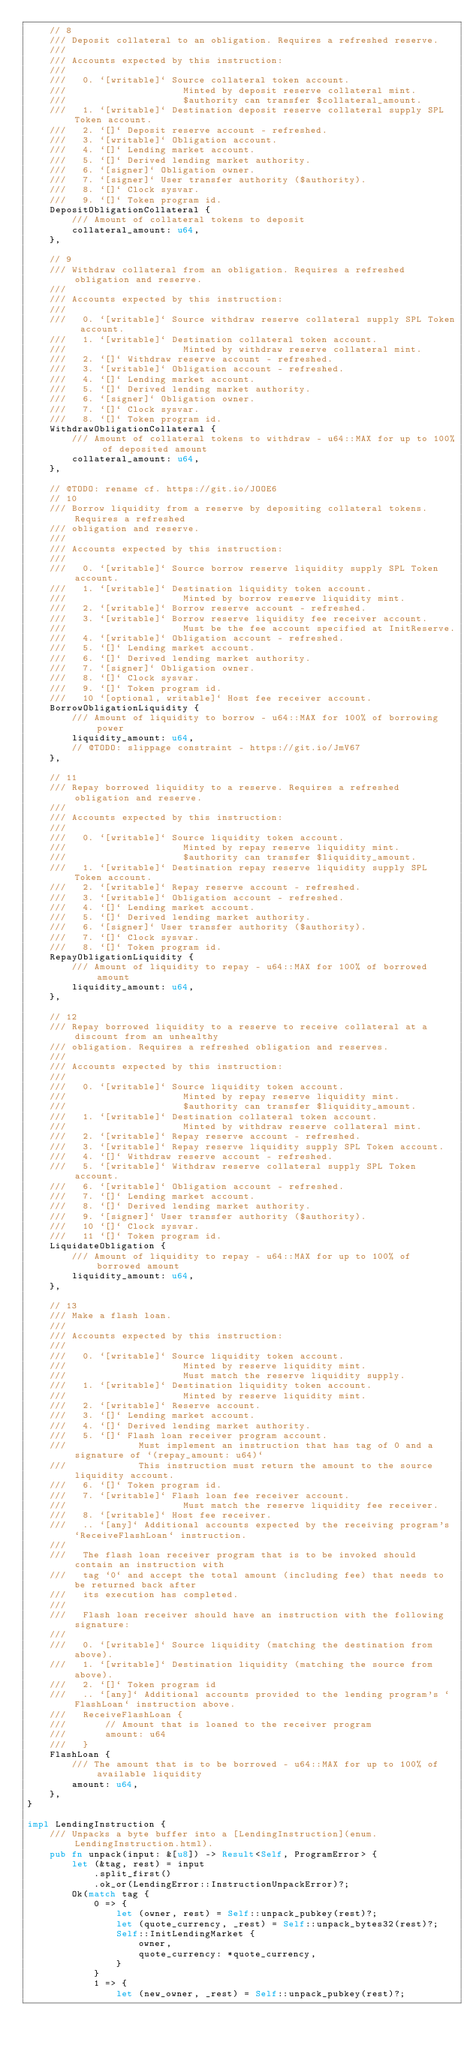<code> <loc_0><loc_0><loc_500><loc_500><_Rust_>    // 8
    /// Deposit collateral to an obligation. Requires a refreshed reserve.
    ///
    /// Accounts expected by this instruction:
    ///
    ///   0. `[writable]` Source collateral token account.
    ///                     Minted by deposit reserve collateral mint.
    ///                     $authority can transfer $collateral_amount.
    ///   1. `[writable]` Destination deposit reserve collateral supply SPL Token account.
    ///   2. `[]` Deposit reserve account - refreshed.
    ///   3. `[writable]` Obligation account.
    ///   4. `[]` Lending market account.
    ///   5. `[]` Derived lending market authority.
    ///   6. `[signer]` Obligation owner.
    ///   7. `[signer]` User transfer authority ($authority).
    ///   8. `[]` Clock sysvar.
    ///   9. `[]` Token program id.
    DepositObligationCollateral {
        /// Amount of collateral tokens to deposit
        collateral_amount: u64,
    },

    // 9
    /// Withdraw collateral from an obligation. Requires a refreshed obligation and reserve.
    ///
    /// Accounts expected by this instruction:
    ///
    ///   0. `[writable]` Source withdraw reserve collateral supply SPL Token account.
    ///   1. `[writable]` Destination collateral token account.
    ///                     Minted by withdraw reserve collateral mint.
    ///   2. `[]` Withdraw reserve account - refreshed.
    ///   3. `[writable]` Obligation account - refreshed.
    ///   4. `[]` Lending market account.
    ///   5. `[]` Derived lending market authority.
    ///   6. `[signer]` Obligation owner.
    ///   7. `[]` Clock sysvar.
    ///   8. `[]` Token program id.
    WithdrawObligationCollateral {
        /// Amount of collateral tokens to withdraw - u64::MAX for up to 100% of deposited amount
        collateral_amount: u64,
    },

    // @TODO: rename cf. https://git.io/JOOE6
    // 10
    /// Borrow liquidity from a reserve by depositing collateral tokens. Requires a refreshed
    /// obligation and reserve.
    ///
    /// Accounts expected by this instruction:
    ///
    ///   0. `[writable]` Source borrow reserve liquidity supply SPL Token account.
    ///   1. `[writable]` Destination liquidity token account.
    ///                     Minted by borrow reserve liquidity mint.
    ///   2. `[writable]` Borrow reserve account - refreshed.
    ///   3. `[writable]` Borrow reserve liquidity fee receiver account.
    ///                     Must be the fee account specified at InitReserve.
    ///   4. `[writable]` Obligation account - refreshed.
    ///   5. `[]` Lending market account.
    ///   6. `[]` Derived lending market authority.
    ///   7. `[signer]` Obligation owner.
    ///   8. `[]` Clock sysvar.
    ///   9. `[]` Token program id.
    ///   10 `[optional, writable]` Host fee receiver account.
    BorrowObligationLiquidity {
        /// Amount of liquidity to borrow - u64::MAX for 100% of borrowing power
        liquidity_amount: u64,
        // @TODO: slippage constraint - https://git.io/JmV67
    },

    // 11
    /// Repay borrowed liquidity to a reserve. Requires a refreshed obligation and reserve.
    ///
    /// Accounts expected by this instruction:
    ///
    ///   0. `[writable]` Source liquidity token account.
    ///                     Minted by repay reserve liquidity mint.
    ///                     $authority can transfer $liquidity_amount.
    ///   1. `[writable]` Destination repay reserve liquidity supply SPL Token account.
    ///   2. `[writable]` Repay reserve account - refreshed.
    ///   3. `[writable]` Obligation account - refreshed.
    ///   4. `[]` Lending market account.
    ///   5. `[]` Derived lending market authority.
    ///   6. `[signer]` User transfer authority ($authority).
    ///   7. `[]` Clock sysvar.
    ///   8. `[]` Token program id.
    RepayObligationLiquidity {
        /// Amount of liquidity to repay - u64::MAX for 100% of borrowed amount
        liquidity_amount: u64,
    },

    // 12
    /// Repay borrowed liquidity to a reserve to receive collateral at a discount from an unhealthy
    /// obligation. Requires a refreshed obligation and reserves.
    ///
    /// Accounts expected by this instruction:
    ///
    ///   0. `[writable]` Source liquidity token account.
    ///                     Minted by repay reserve liquidity mint.
    ///                     $authority can transfer $liquidity_amount.
    ///   1. `[writable]` Destination collateral token account.
    ///                     Minted by withdraw reserve collateral mint.
    ///   2. `[writable]` Repay reserve account - refreshed.
    ///   3. `[writable]` Repay reserve liquidity supply SPL Token account.
    ///   4. `[]` Withdraw reserve account - refreshed.
    ///   5. `[writable]` Withdraw reserve collateral supply SPL Token account.
    ///   6. `[writable]` Obligation account - refreshed.
    ///   7. `[]` Lending market account.
    ///   8. `[]` Derived lending market authority.
    ///   9. `[signer]` User transfer authority ($authority).
    ///   10 `[]` Clock sysvar.
    ///   11 `[]` Token program id.
    LiquidateObligation {
        /// Amount of liquidity to repay - u64::MAX for up to 100% of borrowed amount
        liquidity_amount: u64,
    },

    // 13
    /// Make a flash loan.
    ///
    /// Accounts expected by this instruction:
    ///
    ///   0. `[writable]` Source liquidity token account.
    ///                     Minted by reserve liquidity mint.
    ///                     Must match the reserve liquidity supply.
    ///   1. `[writable]` Destination liquidity token account.
    ///                     Minted by reserve liquidity mint.
    ///   2. `[writable]` Reserve account.
    ///   3. `[]` Lending market account.
    ///   4. `[]` Derived lending market authority.
    ///   5. `[]` Flash loan receiver program account.
    ///             Must implement an instruction that has tag of 0 and a signature of `(repay_amount: u64)`
    ///             This instruction must return the amount to the source liquidity account.
    ///   6. `[]` Token program id.
    ///   7. `[writable]` Flash loan fee receiver account.
    ///                     Must match the reserve liquidity fee receiver.
    ///   8. `[writable]` Host fee receiver.
    ///   .. `[any]` Additional accounts expected by the receiving program's `ReceiveFlashLoan` instruction.
    ///
    ///   The flash loan receiver program that is to be invoked should contain an instruction with
    ///   tag `0` and accept the total amount (including fee) that needs to be returned back after
    ///   its execution has completed.
    ///
    ///   Flash loan receiver should have an instruction with the following signature:
    ///
    ///   0. `[writable]` Source liquidity (matching the destination from above).
    ///   1. `[writable]` Destination liquidity (matching the source from above).
    ///   2. `[]` Token program id
    ///   .. `[any]` Additional accounts provided to the lending program's `FlashLoan` instruction above.
    ///   ReceiveFlashLoan {
    ///       // Amount that is loaned to the receiver program
    ///       amount: u64
    ///   }
    FlashLoan {
        /// The amount that is to be borrowed - u64::MAX for up to 100% of available liquidity
        amount: u64,
    },
}

impl LendingInstruction {
    /// Unpacks a byte buffer into a [LendingInstruction](enum.LendingInstruction.html).
    pub fn unpack(input: &[u8]) -> Result<Self, ProgramError> {
        let (&tag, rest) = input
            .split_first()
            .ok_or(LendingError::InstructionUnpackError)?;
        Ok(match tag {
            0 => {
                let (owner, rest) = Self::unpack_pubkey(rest)?;
                let (quote_currency, _rest) = Self::unpack_bytes32(rest)?;
                Self::InitLendingMarket {
                    owner,
                    quote_currency: *quote_currency,
                }
            }
            1 => {
                let (new_owner, _rest) = Self::unpack_pubkey(rest)?;</code> 